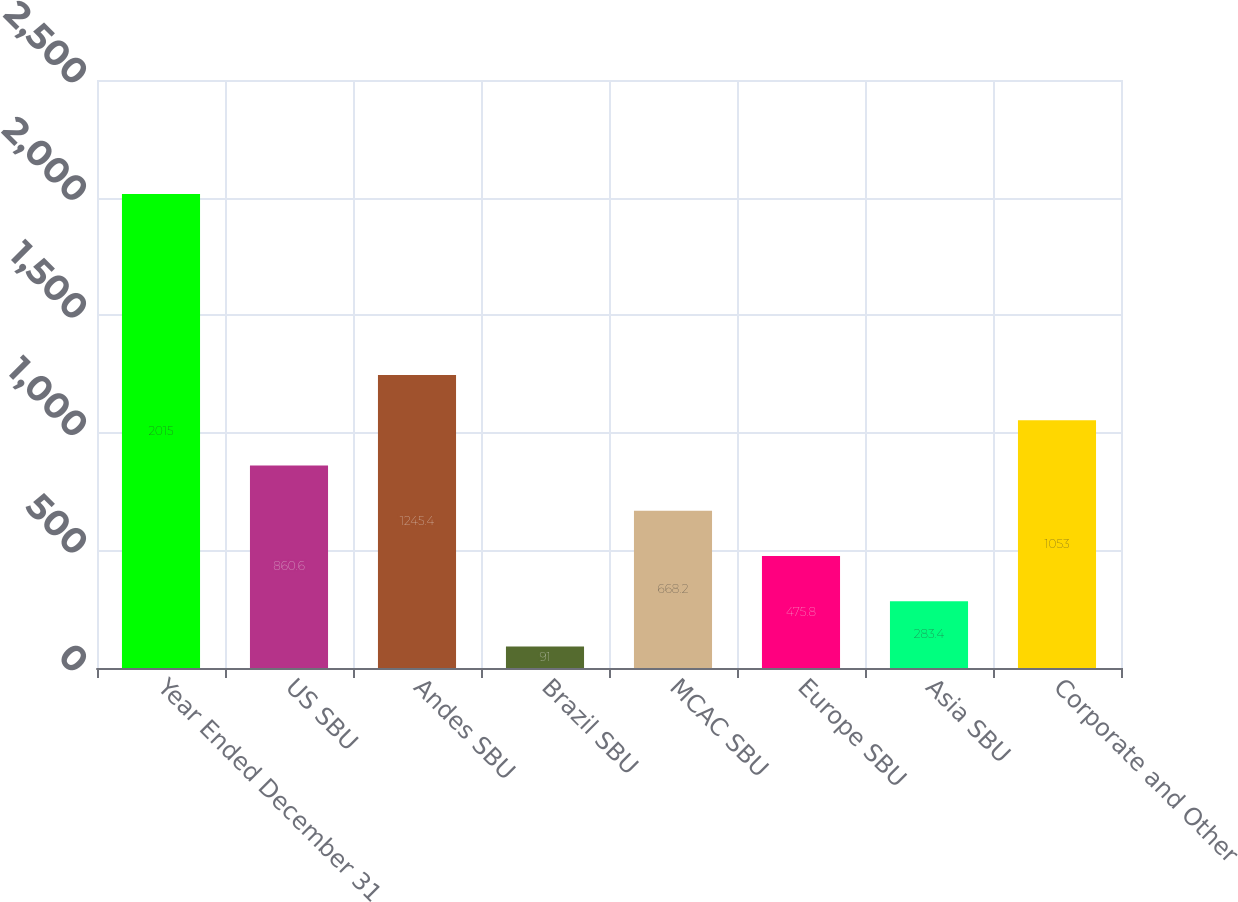Convert chart to OTSL. <chart><loc_0><loc_0><loc_500><loc_500><bar_chart><fcel>Year Ended December 31<fcel>US SBU<fcel>Andes SBU<fcel>Brazil SBU<fcel>MCAC SBU<fcel>Europe SBU<fcel>Asia SBU<fcel>Corporate and Other<nl><fcel>2015<fcel>860.6<fcel>1245.4<fcel>91<fcel>668.2<fcel>475.8<fcel>283.4<fcel>1053<nl></chart> 